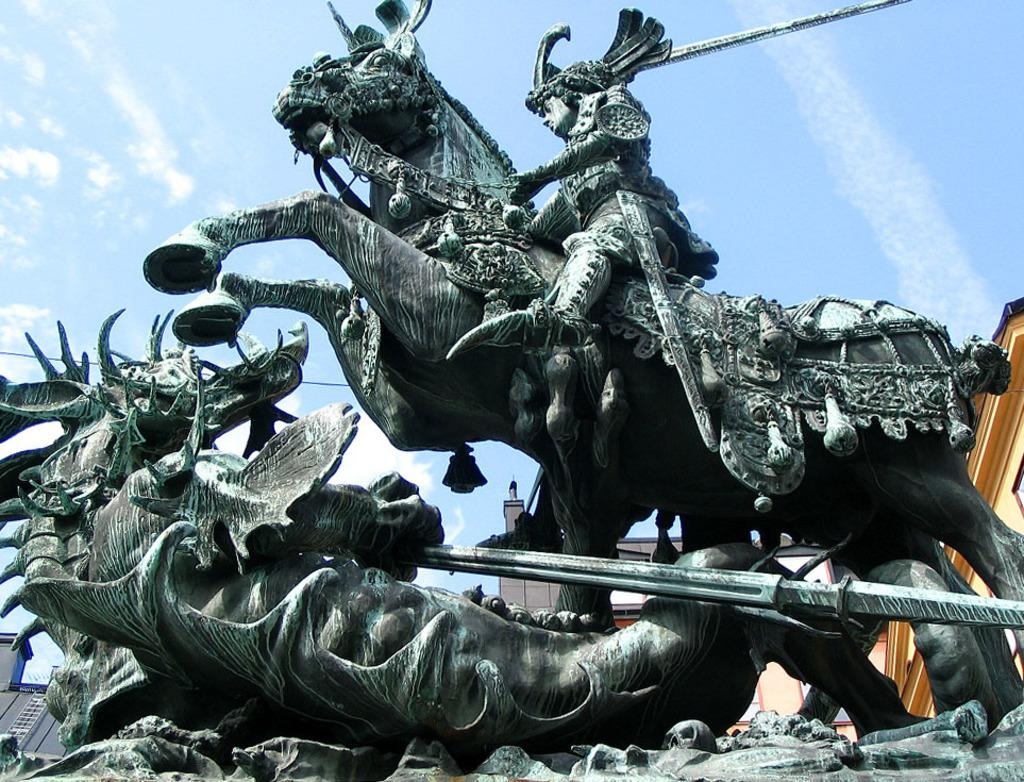What can be seen in the front of the image? There are sculptures in the front of the image. What is visible in the background of the image? There are buildings and clouds visible in the background of the image. What part of the natural environment is visible in the image? The sky is visible in the background of the image. How many dimes are scattered on the sidewalk in the image? There is no mention of dimes or a sidewalk in the image; it features sculptures in the front and buildings and clouds in the background. What type of art is displayed on the buildings in the image? The provided facts do not mention any specific art on the buildings; they only mention the presence of buildings in the background. 